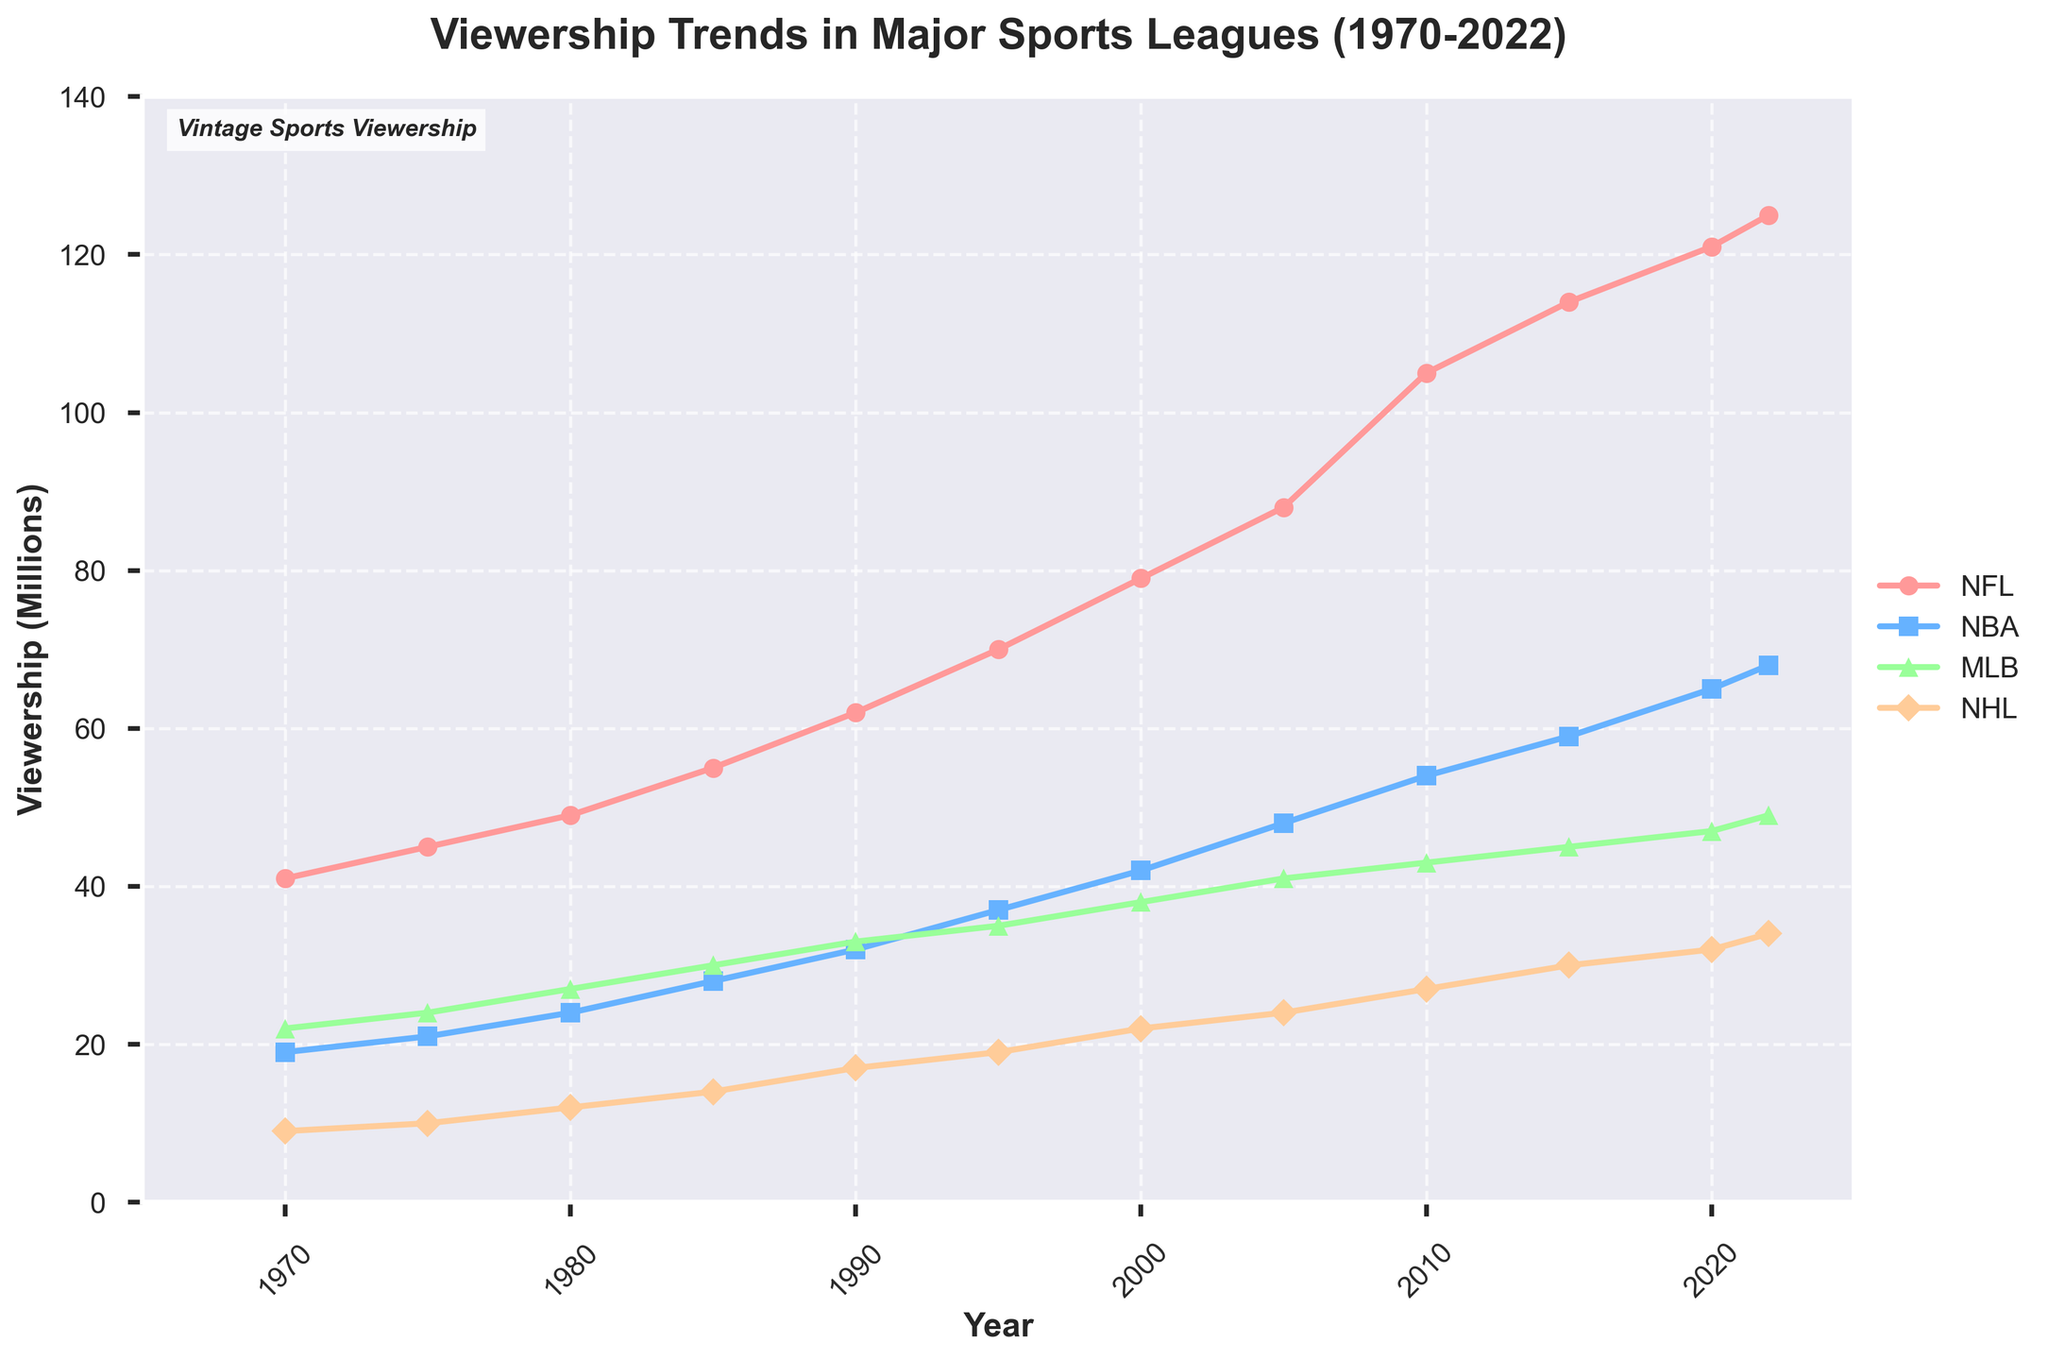what is the overall trend of viewership for NFL from 1970 to 2022? The line for NFL viewership is consistently increasing from 1970 to 2022, indicating an overall upward trend.
Answer: Increasing Between which years did NBA viewership experience the most significant increase? By looking at the slopes of the NBA line, the most significant increase in viewership appears between 2005 and 2010.
Answer: 2005 to 2010 In 1995, how does the viewership of the NHL compare to the viewership of the MLB? In 1995, the NHL viewership is 19 million, whereas the MLB viewership is 35 million. Thus, the NHL has significantly lower viewership than the MLB.
Answer: Lower At what year did MLB viewership first exceed 30 million? By examining the MLB line, the first year it crosses the 30 million mark is between 1985 and 1990, so the exact first year is 1990.
Answer: 1990 Which league has the highest viewership in 2022? Looking at the endpoints for 2022, the NFL has the highest viewership at 125 million.
Answer: NFL What is the combined viewership of NFL and NBA in 2022? Add the viewership numbers for NFL and NBA in 2022: 125 million + 68 million = 193 million.
Answer: 193 million Between 1970 and 2022, which league had the least consistent growth in viewership? By observing the overall trend lines, the NHL has the least consistent growth as its line is less steep and more fluctuating compared to the others.
Answer: NHL What was the viewership difference between the NFL and NBA in 2010? The viewership for NFL in 2010 was 105 million and for NBA was 54 million. The difference is 105 million - 54 million = 51 million.
Answer: 51 million Which league had the slowest growth in viewership from 2000 to 2022? Comparing the slope of the lines between 2000 and 2022, the MLB line shows the slowest growth.
Answer: MLB 